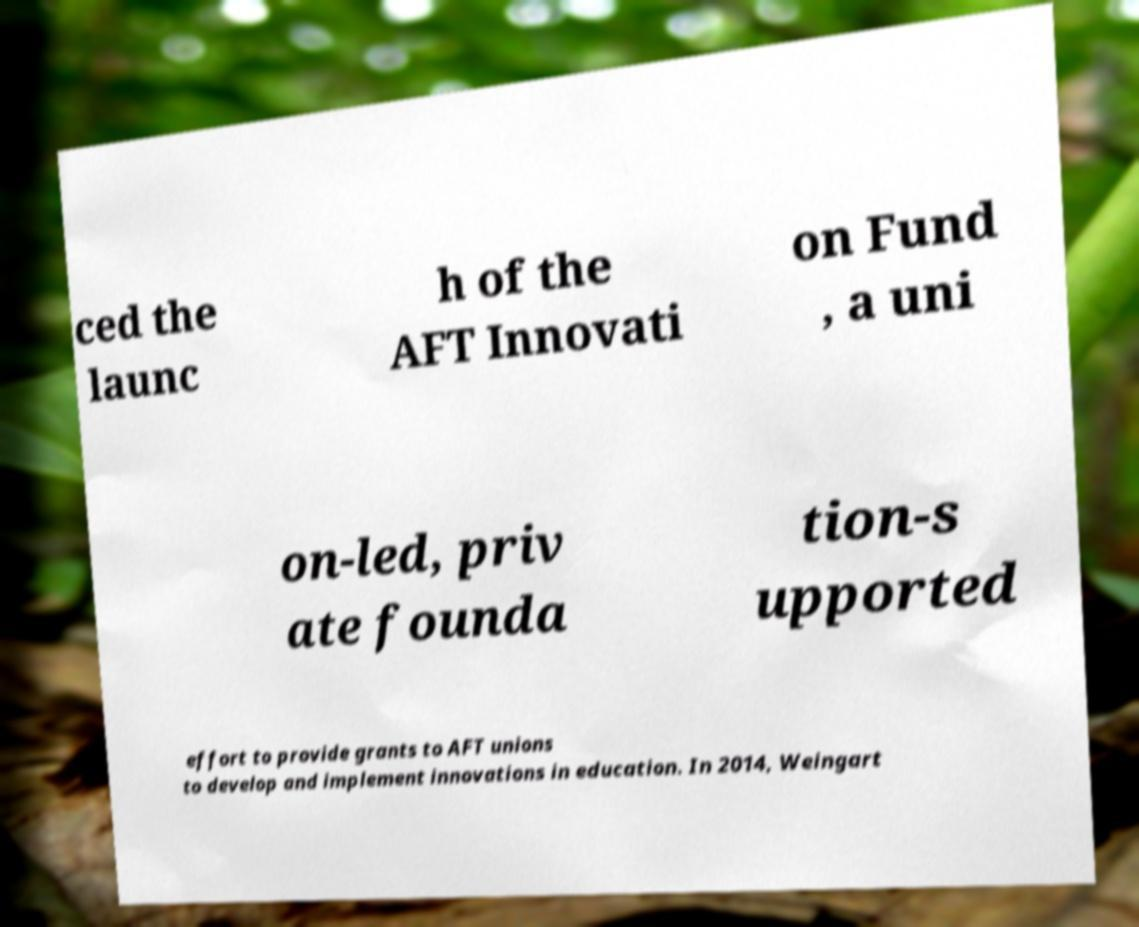Could you extract and type out the text from this image? ced the launc h of the AFT Innovati on Fund , a uni on-led, priv ate founda tion-s upported effort to provide grants to AFT unions to develop and implement innovations in education. In 2014, Weingart 